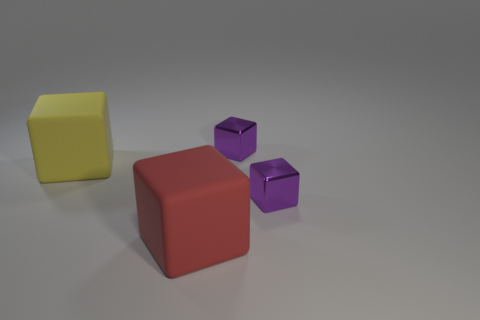Subtract all blue cubes. Subtract all purple balls. How many cubes are left? 4 Add 2 big gray blocks. How many objects exist? 6 Add 1 big red cubes. How many big red cubes are left? 2 Add 4 small purple metallic objects. How many small purple metallic objects exist? 6 Subtract 0 blue cylinders. How many objects are left? 4 Subtract all tiny things. Subtract all purple metal objects. How many objects are left? 0 